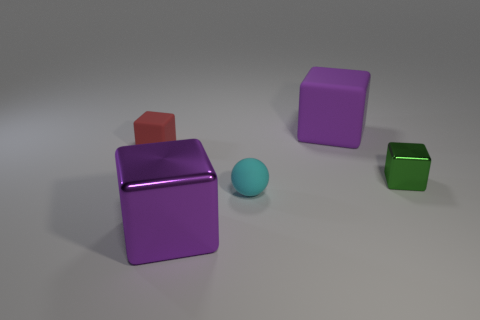Subtract all gray cubes. Subtract all red cylinders. How many cubes are left? 4 Add 3 blue shiny cylinders. How many objects exist? 8 Subtract all cubes. How many objects are left? 1 Subtract 0 blue cylinders. How many objects are left? 5 Subtract all tiny brown objects. Subtract all cyan rubber things. How many objects are left? 4 Add 3 tiny cyan objects. How many tiny cyan objects are left? 4 Add 5 spheres. How many spheres exist? 6 